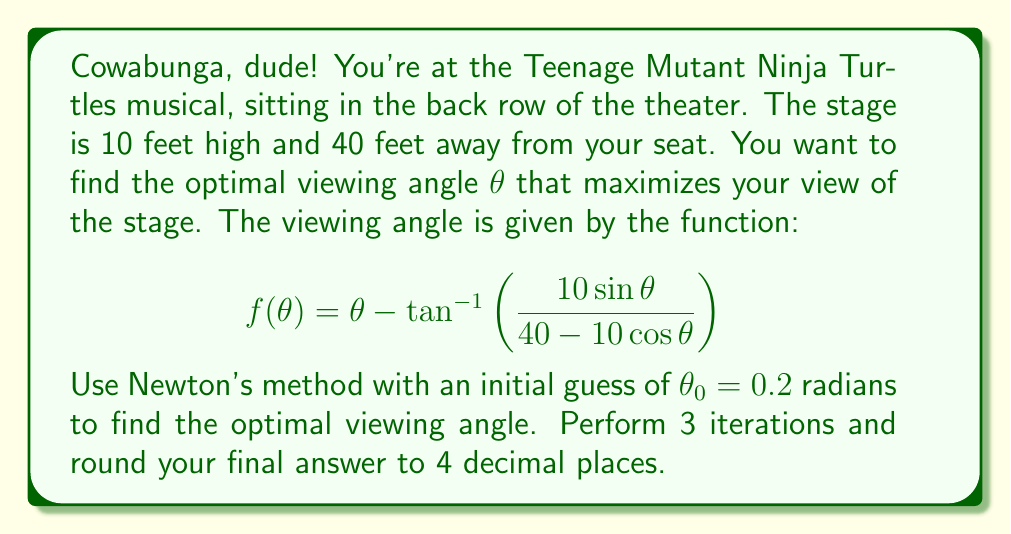Provide a solution to this math problem. To solve this problem using Newton's method, we need to follow these steps:

1) Newton's method formula: $\theta_{n+1} = \theta_n - \frac{f(\theta_n)}{f'(\theta_n)}$

2) We need to find $f'(\theta)$:
   $$ f'(\theta) = 1 - \frac{400}{(40-10\cos\theta)^2 + 100\sin^2\theta} $$

3) Now, let's perform 3 iterations:

   Iteration 1:
   $f(0.2) = 0.2 - \tan^{-1}\left(\frac{10\sin(0.2)}{40-10\cos(0.2)}\right) = 0.1007$
   $f'(0.2) = 0.0598$
   $\theta_1 = 0.2 - \frac{0.1007}{0.0598} = -1.4835$

   Iteration 2:
   $f(-1.4835) = -1.4835 - \tan^{-1}\left(\frac{10\sin(-1.4835)}{40-10\cos(-1.4835)}\right) = -1.7322$
   $f'(-1.4835) = -0.9402$
   $\theta_2 = -1.4835 - \frac{-1.7322}{-0.9402} = 0.3591$

   Iteration 3:
   $f(0.3591) = 0.3591 - \tan^{-1}\left(\frac{10\sin(0.3591)}{40-10\cos(0.3591)}\right) = 0.1787$
   $f'(0.3591) = 0.1062$
   $\theta_3 = 0.3591 - \frac{0.1787}{0.1062} = -1.3239$

4) Rounding $\theta_3$ to 4 decimal places gives us -1.3239 radians.
Answer: -1.3239 radians 